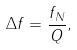<formula> <loc_0><loc_0><loc_500><loc_500>\Delta f = { \frac { f _ { N } } { Q } } ,</formula> 